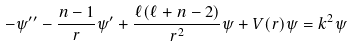<formula> <loc_0><loc_0><loc_500><loc_500>- \psi ^ { \prime \prime } - \frac { n - 1 } { r } \psi ^ { \prime } + \frac { \ell ( \ell + n - 2 ) } { r ^ { 2 } } \psi + V ( r ) \psi = k ^ { 2 } \psi</formula> 